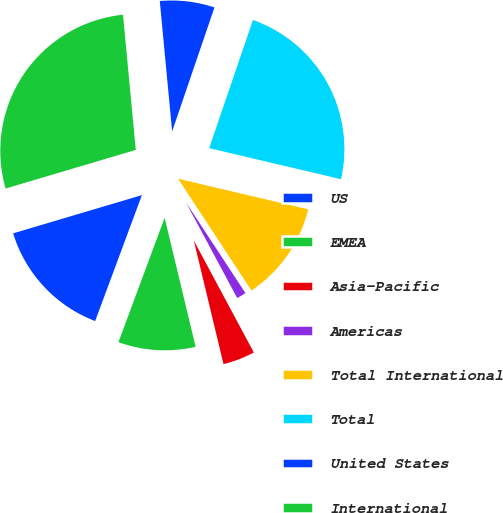<chart> <loc_0><loc_0><loc_500><loc_500><pie_chart><fcel>US<fcel>EMEA<fcel>Asia-Pacific<fcel>Americas<fcel>Total International<fcel>Total<fcel>United States<fcel>International<nl><fcel>14.75%<fcel>9.41%<fcel>4.08%<fcel>1.41%<fcel>12.08%<fcel>23.44%<fcel>6.74%<fcel>28.09%<nl></chart> 